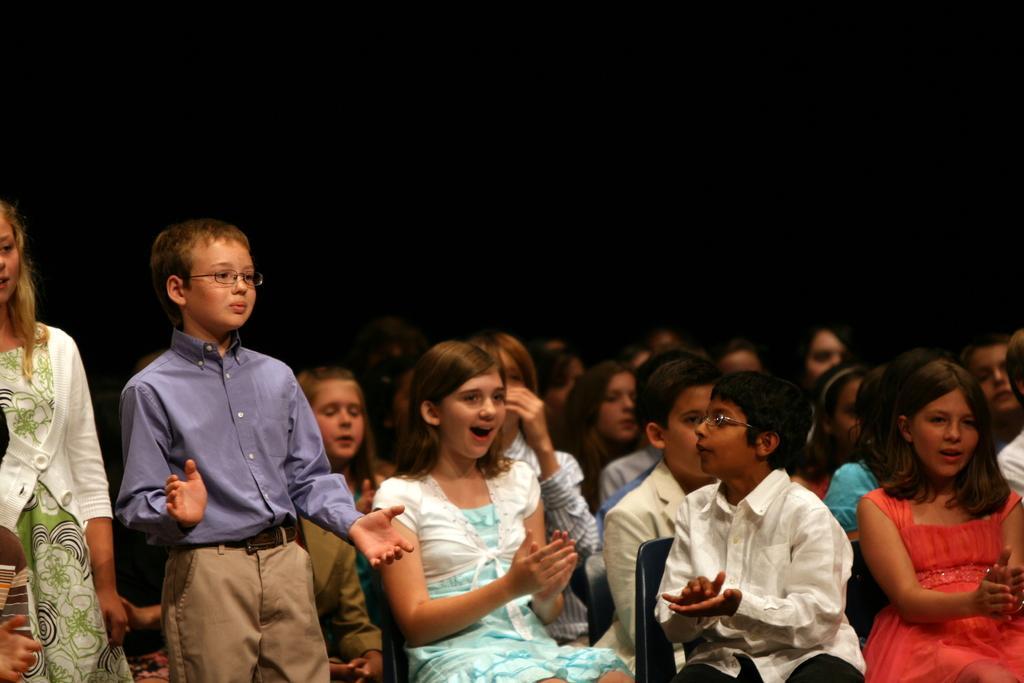Can you describe this image briefly? In this image, we can see people sitting on the chairs and some are standing and the background is in black color. 